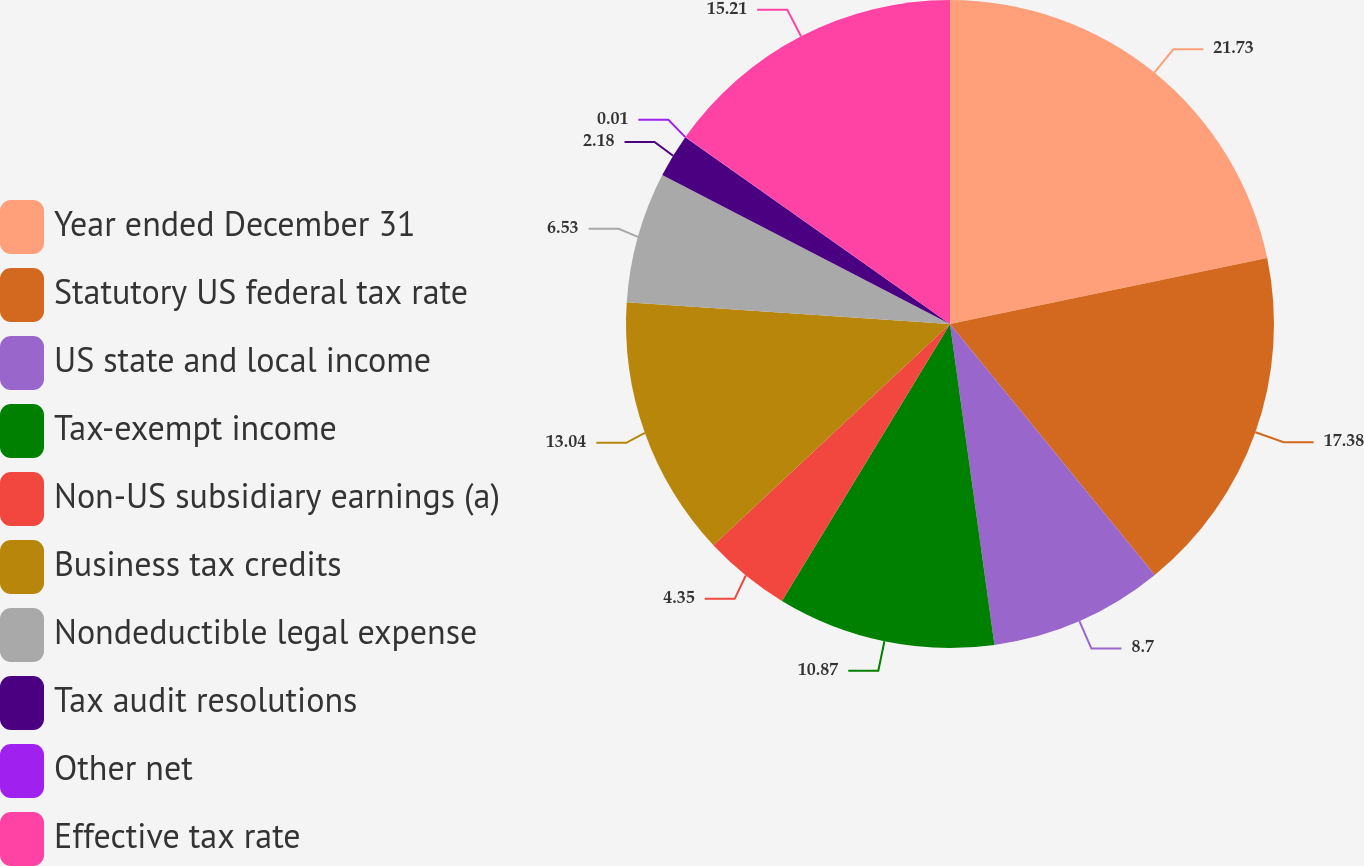Convert chart to OTSL. <chart><loc_0><loc_0><loc_500><loc_500><pie_chart><fcel>Year ended December 31<fcel>Statutory US federal tax rate<fcel>US state and local income<fcel>Tax-exempt income<fcel>Non-US subsidiary earnings (a)<fcel>Business tax credits<fcel>Nondeductible legal expense<fcel>Tax audit resolutions<fcel>Other net<fcel>Effective tax rate<nl><fcel>21.73%<fcel>17.38%<fcel>8.7%<fcel>10.87%<fcel>4.35%<fcel>13.04%<fcel>6.53%<fcel>2.18%<fcel>0.01%<fcel>15.21%<nl></chart> 